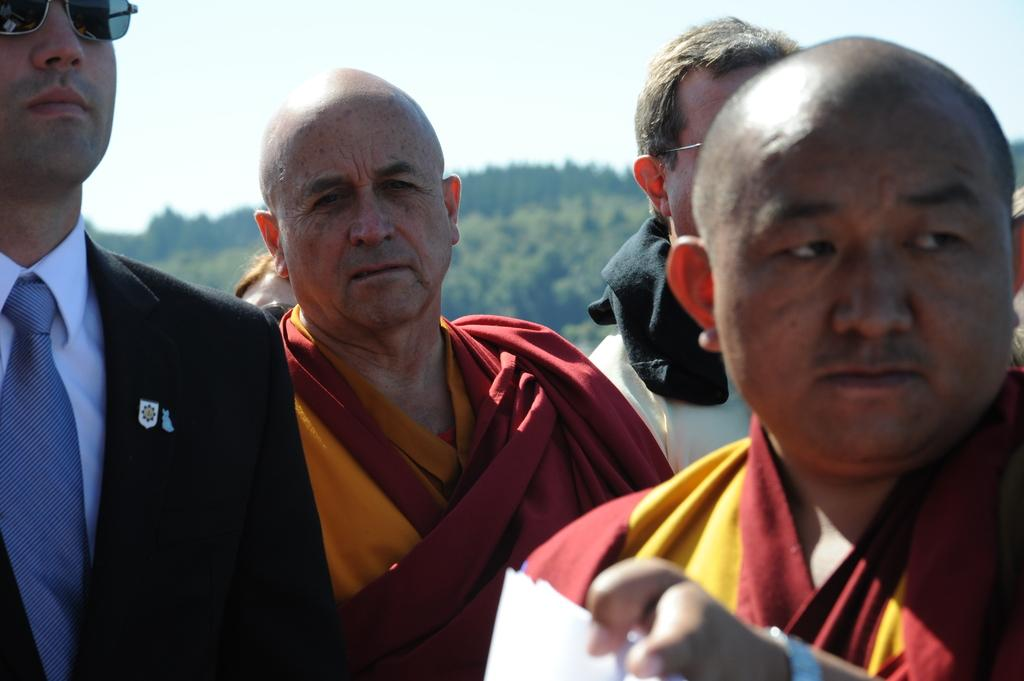What is the main subject of the image? There are people in the center of the image. What can be seen in the background of the image? There are mountains in the background of the image. What is visible at the top of the image? The sky is visible at the top of the image. What type of plane is flying over the people in the image? There is no plane visible in the image; it only features people, mountains, and the sky. 